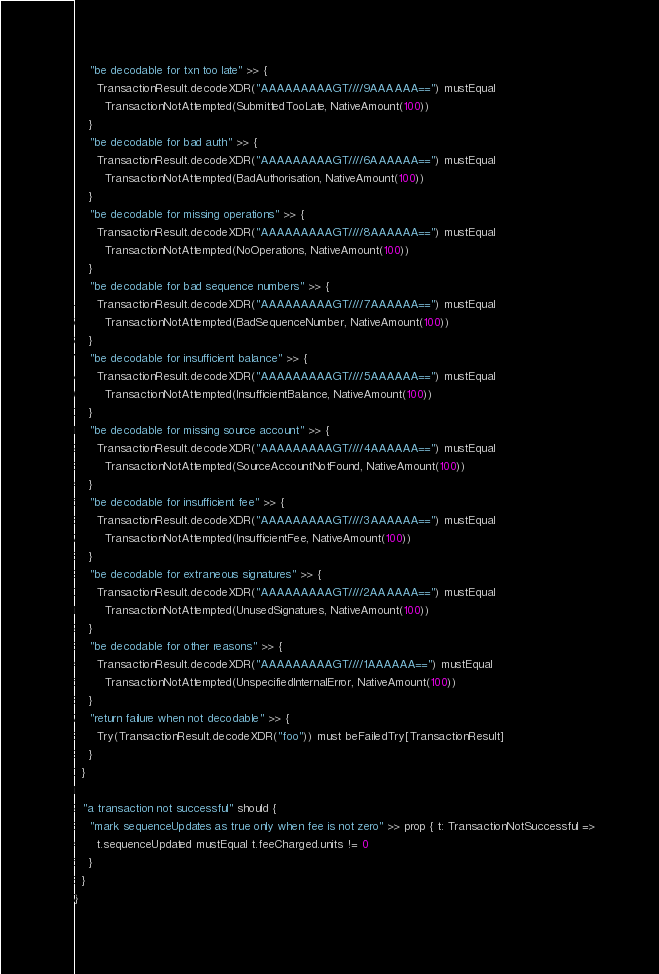Convert code to text. <code><loc_0><loc_0><loc_500><loc_500><_Scala_>    "be decodable for txn too late" >> {
      TransactionResult.decodeXDR("AAAAAAAAAGT////9AAAAAA==") mustEqual
        TransactionNotAttempted(SubmittedTooLate, NativeAmount(100))
    }
    "be decodable for bad auth" >> {
      TransactionResult.decodeXDR("AAAAAAAAAGT////6AAAAAA==") mustEqual
        TransactionNotAttempted(BadAuthorisation, NativeAmount(100))
    }
    "be decodable for missing operations" >> {
      TransactionResult.decodeXDR("AAAAAAAAAGT////8AAAAAA==") mustEqual
        TransactionNotAttempted(NoOperations, NativeAmount(100))
    }
    "be decodable for bad sequence numbers" >> {
      TransactionResult.decodeXDR("AAAAAAAAAGT////7AAAAAA==") mustEqual
        TransactionNotAttempted(BadSequenceNumber, NativeAmount(100))
    }
    "be decodable for insufficient balance" >> {
      TransactionResult.decodeXDR("AAAAAAAAAGT////5AAAAAA==") mustEqual
        TransactionNotAttempted(InsufficientBalance, NativeAmount(100))
    }
    "be decodable for missing source account" >> {
      TransactionResult.decodeXDR("AAAAAAAAAGT////4AAAAAA==") mustEqual
        TransactionNotAttempted(SourceAccountNotFound, NativeAmount(100))
    }
    "be decodable for insufficient fee" >> {
      TransactionResult.decodeXDR("AAAAAAAAAGT////3AAAAAA==") mustEqual
        TransactionNotAttempted(InsufficientFee, NativeAmount(100))
    }
    "be decodable for extraneous signatures" >> {
      TransactionResult.decodeXDR("AAAAAAAAAGT////2AAAAAA==") mustEqual
        TransactionNotAttempted(UnusedSignatures, NativeAmount(100))
    }
    "be decodable for other reasons" >> {
      TransactionResult.decodeXDR("AAAAAAAAAGT////1AAAAAA==") mustEqual
        TransactionNotAttempted(UnspecifiedInternalError, NativeAmount(100))
    }
    "return failure when not decodable" >> {
      Try(TransactionResult.decodeXDR("foo")) must beFailedTry[TransactionResult]
    }
  }

  "a transaction not successful" should {
    "mark sequenceUpdates as true only when fee is not zero" >> prop { t: TransactionNotSuccessful =>
      t.sequenceUpdated mustEqual t.feeCharged.units != 0
    }
  }
}
</code> 